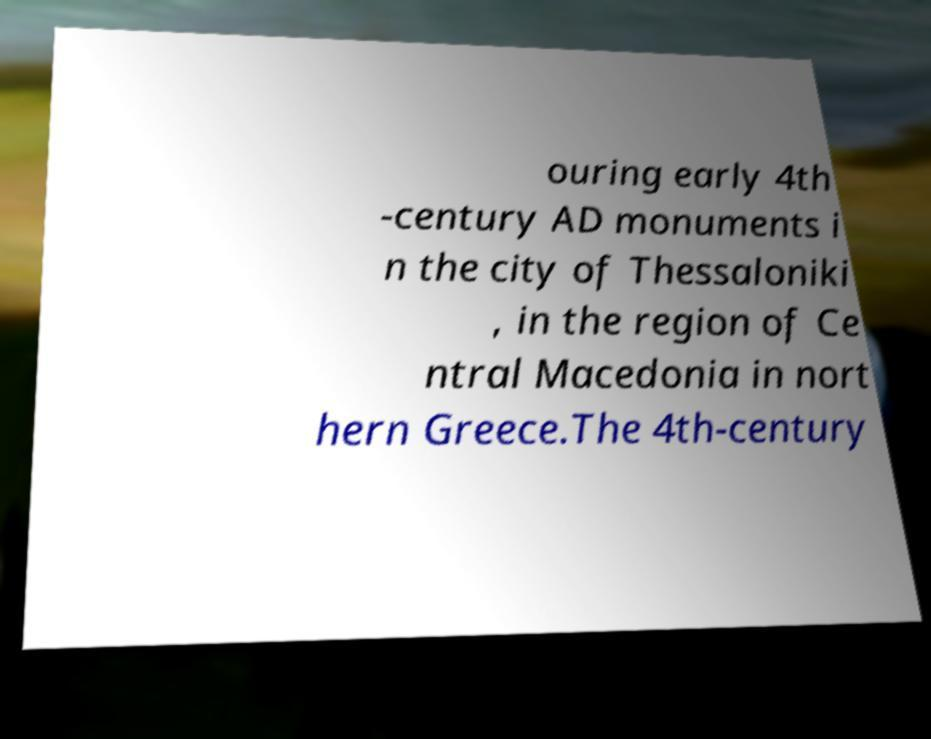Can you accurately transcribe the text from the provided image for me? ouring early 4th -century AD monuments i n the city of Thessaloniki , in the region of Ce ntral Macedonia in nort hern Greece.The 4th-century 